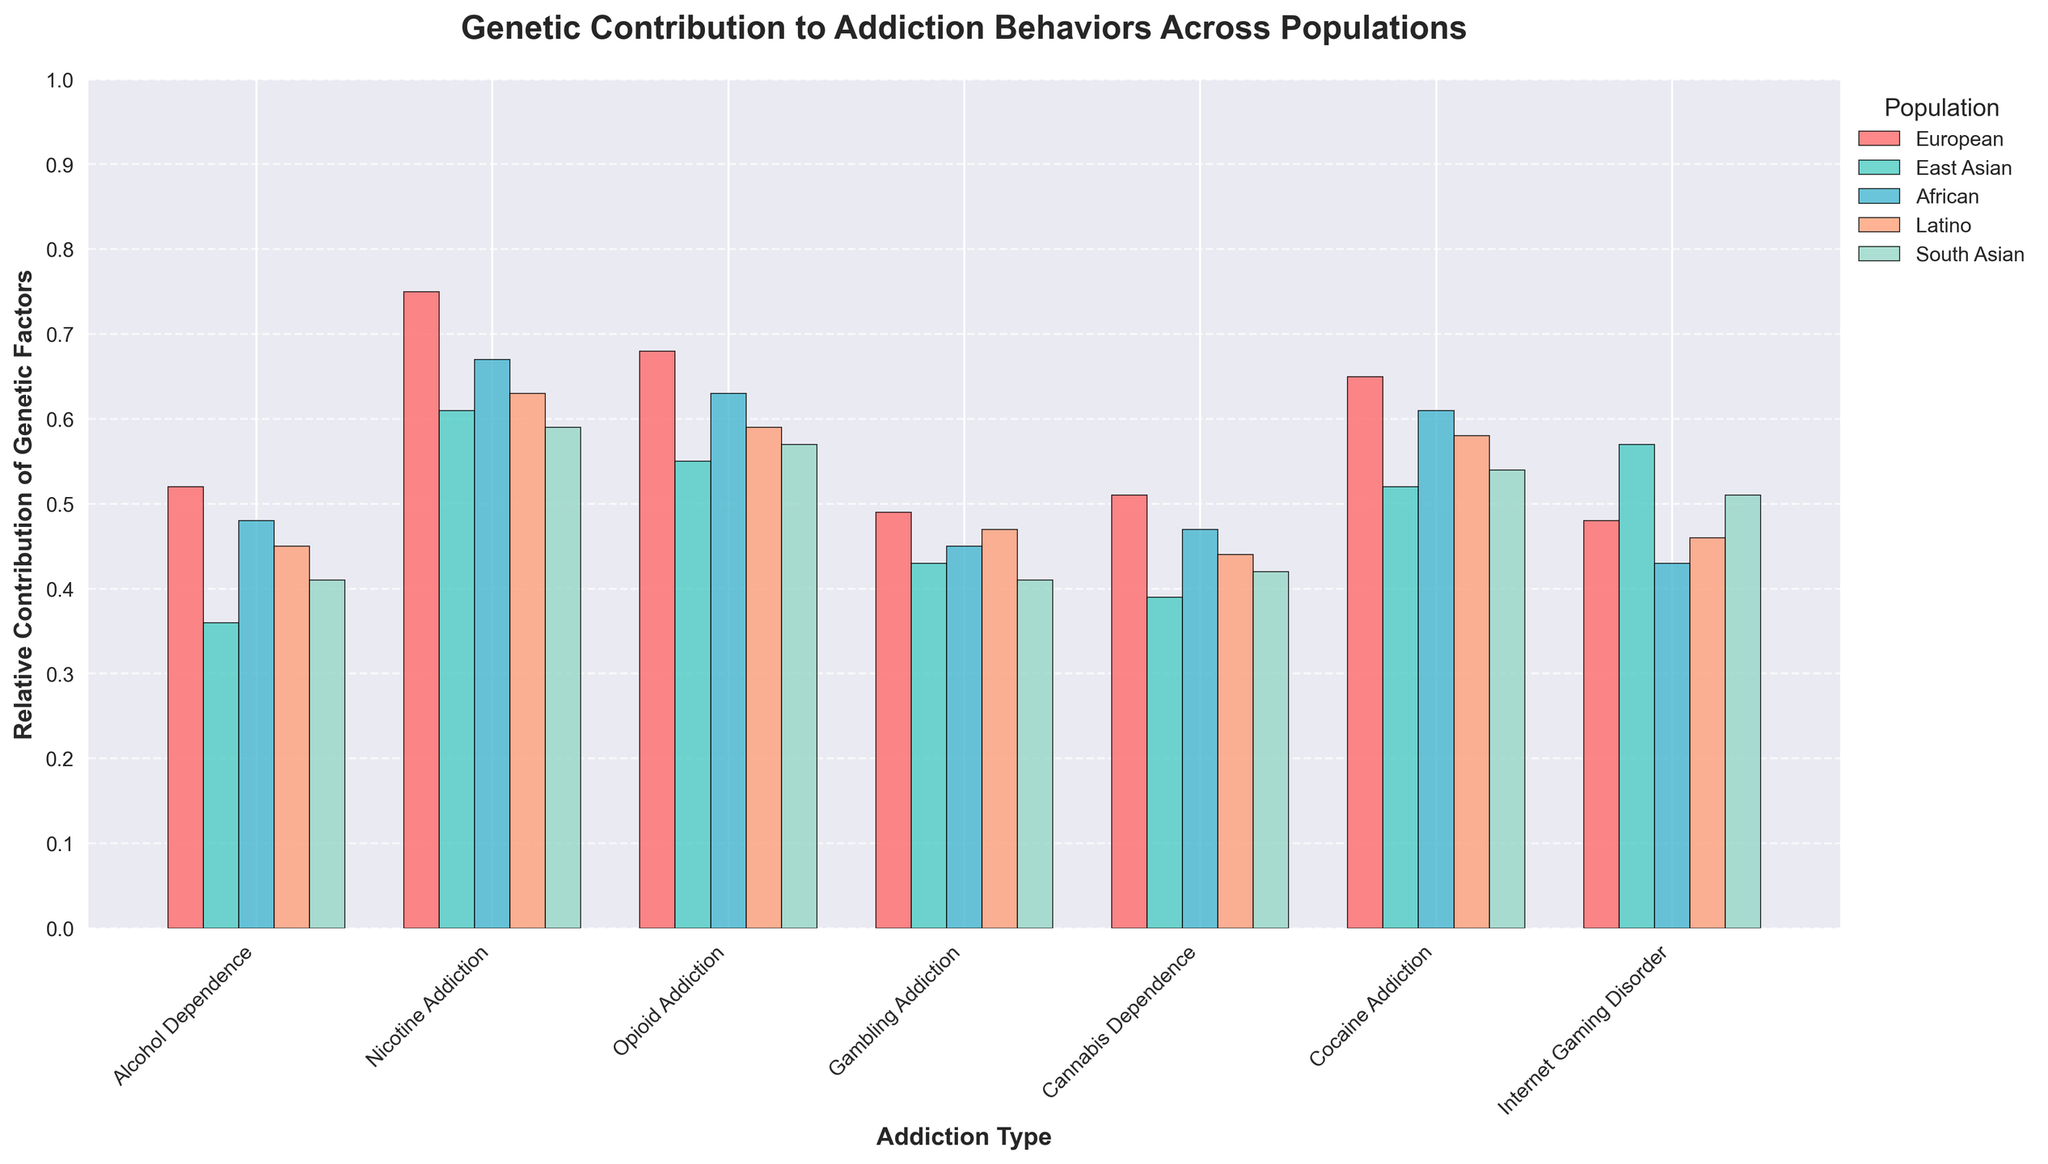What population shows the highest genetic contribution to Nicotine Addiction? The highest bar for Nicotine Addiction corresponds to the European population.
Answer: European Which population has the lowest genetic contribution for Opioid Addiction, and what is that value? The bar for Opioid Addiction with the lowest height is for the South Asian population, which has a value of 0.57.
Answer: South Asian, 0.57 What is the overall genetic contribution for Cannabis Dependence across all populations? Sum the values of Cannabis Dependence for each population: 0.51 (European) + 0.39 (East Asian) + 0.47 (African) + 0.44 (Latino) + 0.42 (South Asian) = 2.23.
Answer: 2.23 How does the genetic contribution for Cocaine Addiction in the African population compare to that in the Latino population? The value for Cocaine Addiction in the African population is 0.61 and in the Latino population is 0.58; African has a higher value.
Answer: African is higher 